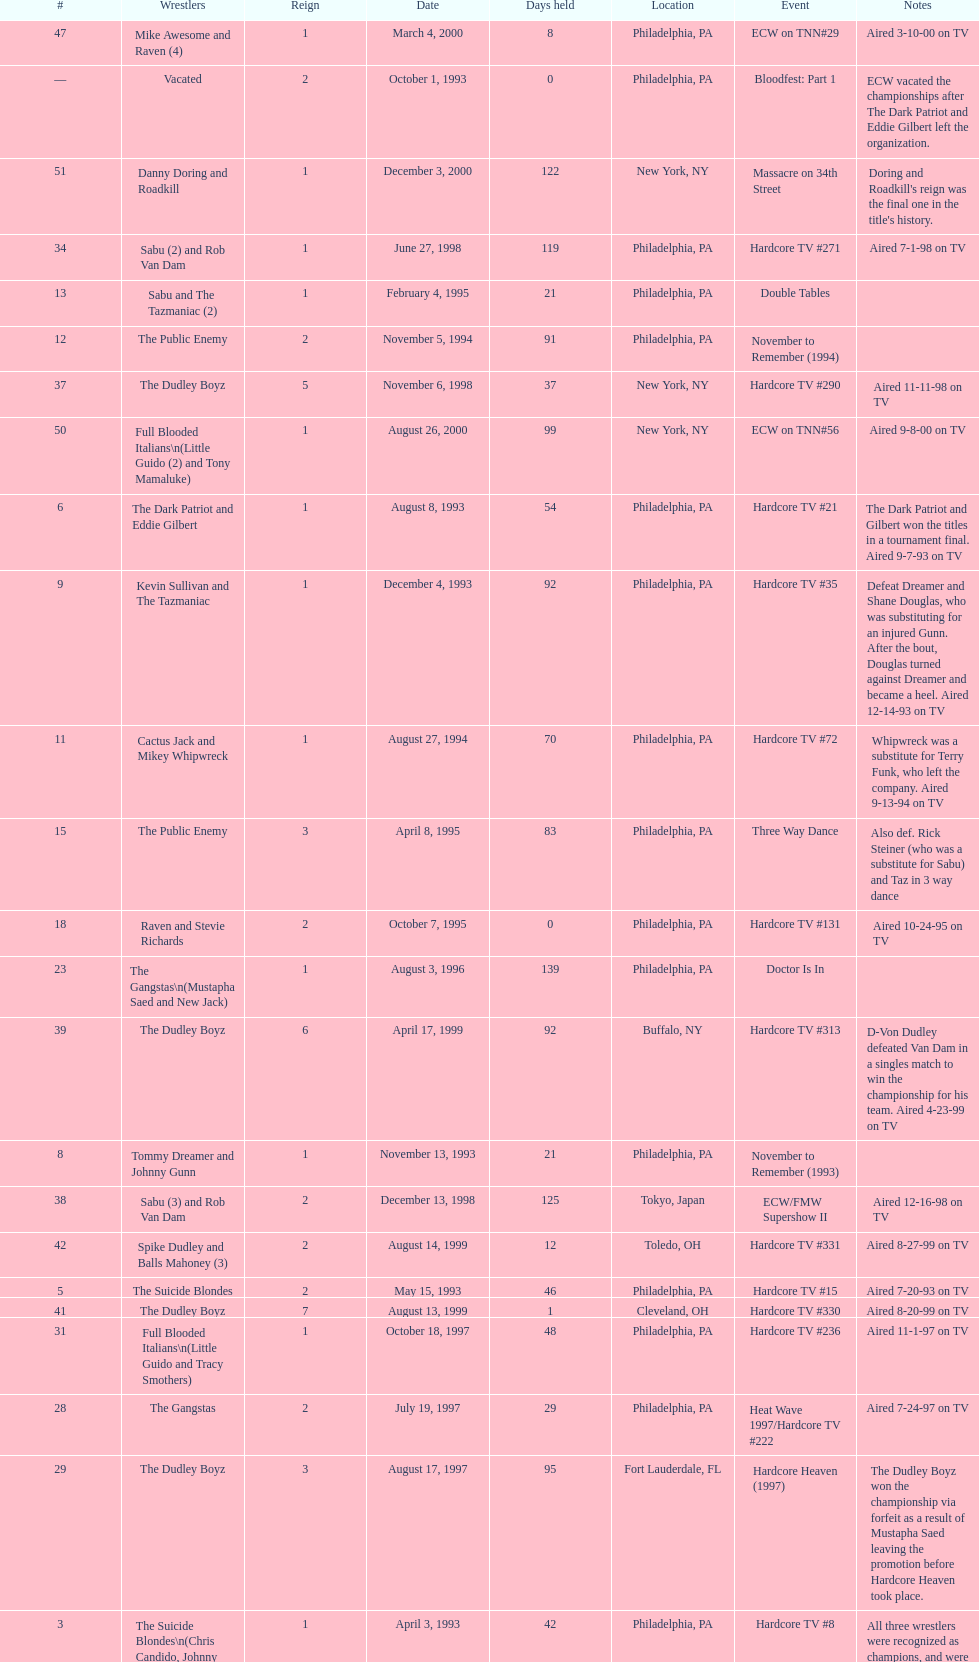Which was the only team to win by forfeit? The Dudley Boyz. 